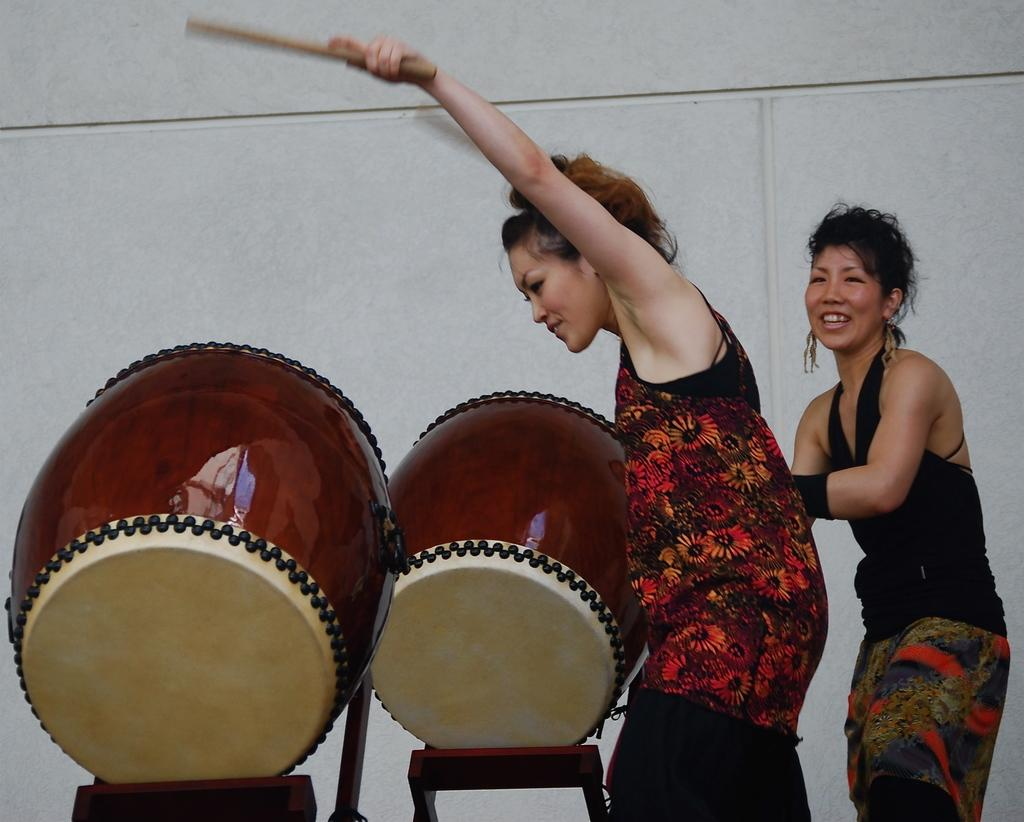How many people are in the image? There are two ladies in the image. What is one of the ladies holding? One lady is holding a stick. What else can be seen in the image besides the ladies? There are musical instruments in the image. What is visible in the background of the image? There is a wall in the background of the image. What type of reward can be seen hanging from the wall in the image? There is no reward visible in the image; only a wall is present in the background. How many cars are parked near the ladies in the image? There are no cars present in the image; it features two ladies and musical instruments. 